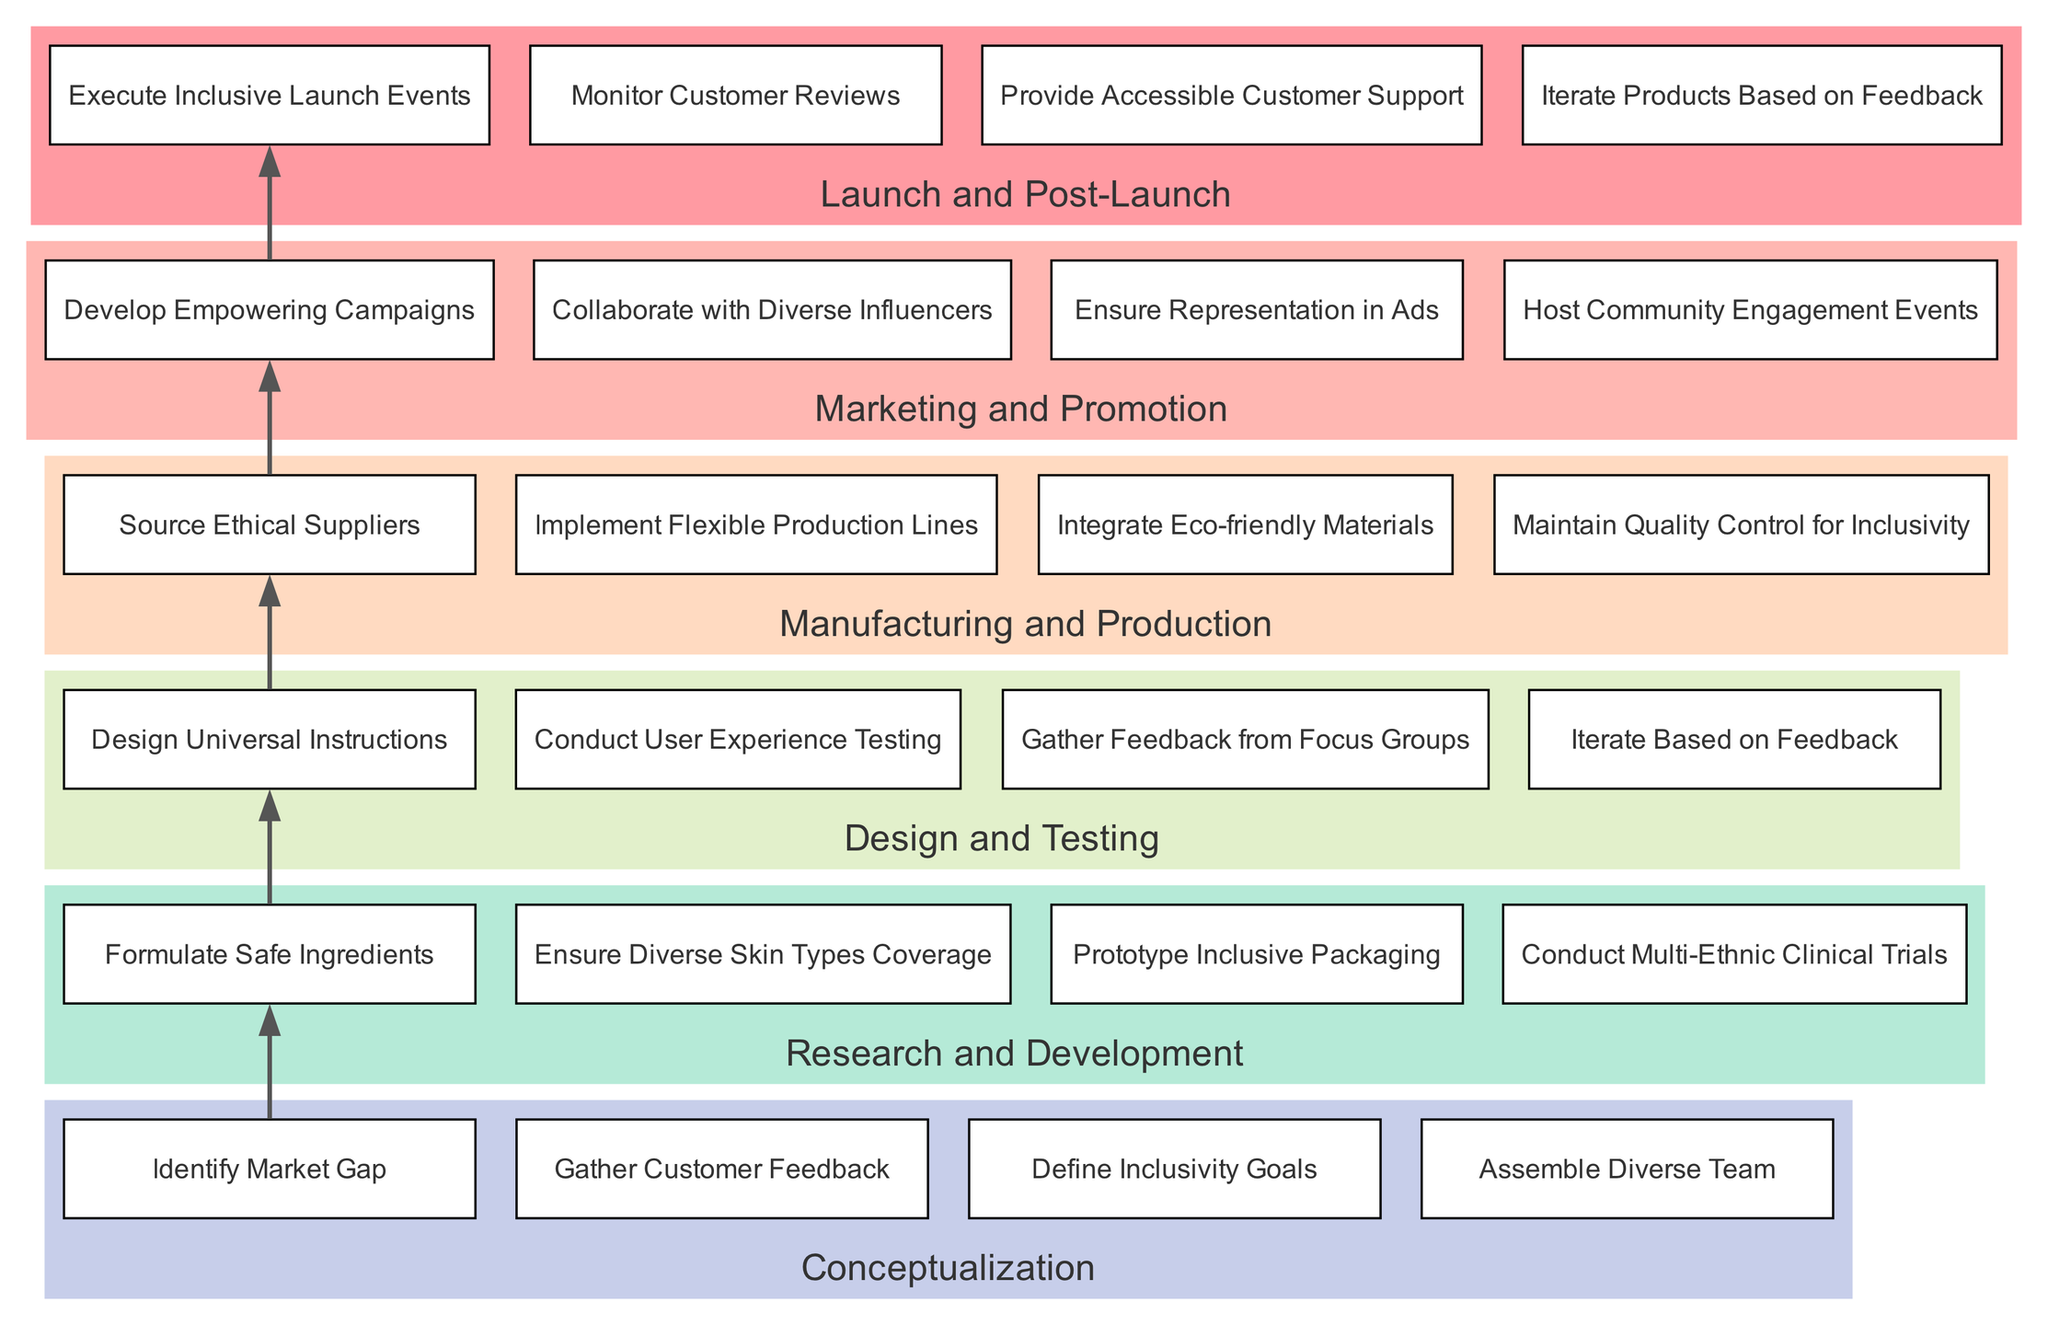What is the first stage in the diagram? The first stage in the diagram is located at the bottom of the flow, which represents the initial part of the process. It is labeled as "Conceptualization."
Answer: Conceptualization How many activities are involved in the "Research and Development" stage? To find this, we count the number of activities listed under the "Research and Development" stage. There are four activities mentioned: "Formulate Safe Ingredients," "Ensure Diverse Skin Types Coverage," "Prototype Inclusive Packaging," and "Conduct Multi-Ethnic Clinical Trials."
Answer: 4 What connects "Design and Testing" to "Manufacturing and Production"? The connection between stages is indicated by an edge drawn from the last activity of "Design and Testing" to the first activity of "Manufacturing and Production." The edge signifies the flow from one stage to the next in the lifecycle.
Answer: An edge What activities are performed during "Marketing and Promotion"? We look at the activities listed under "Marketing and Promotion," which include "Develop Empowering Campaigns," "Collaborate with Diverse Influencers," "Ensure Representation in Ads," and "Host Community Engagement Events." There are four specified activities in this stage.
Answer: Four activities Which stage includes "Monitor Customer Reviews"? The activity "Monitor Customer Reviews" is listed under the last stage, which is "Launch and Post-Launch." This helps us identify that this stage focuses on evaluation and adjustments after product launch.
Answer: Launch and Post-Launch How many different stages are represented in the diagram? The total number of stages is determined by counting each stage from bottom to top in the diagram, which includes "Conceptualization," "Research and Development," "Design and Testing," "Manufacturing and Production," "Marketing and Promotion," and "Launch and Post-Launch." There are six stages in total.
Answer: 6 What is the purpose of including a diverse team in the "Conceptualization" stage? The purpose of including a diverse team is to ensure that various perspectives are considered which contributes to defining inclusivity goals, ultimately influencing the entire product development lifecycle positively. This can improve product relevance and acceptance across a wider audience.
Answer: To define inclusivity goals What is the last activity in the "Manufacturing and Production" stage? By examining the list of activities under "Manufacturing and Production," we note that the last activity mentioned is "Maintain Quality Control for Inclusivity," which ensures that inclusivity is upheld throughout the manufacturing process.
Answer: Maintain Quality Control for Inclusivity 